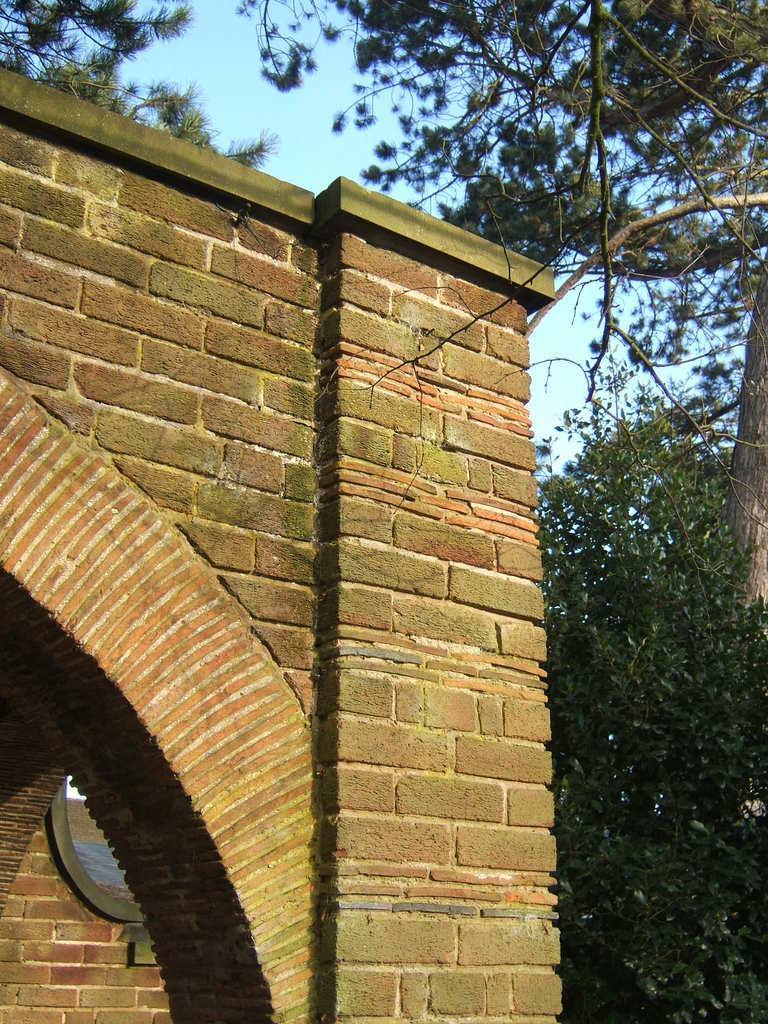In one or two sentences, can you explain what this image depicts? There is a building with arch. On the sides of the building there are trees. In the background there is sky. 